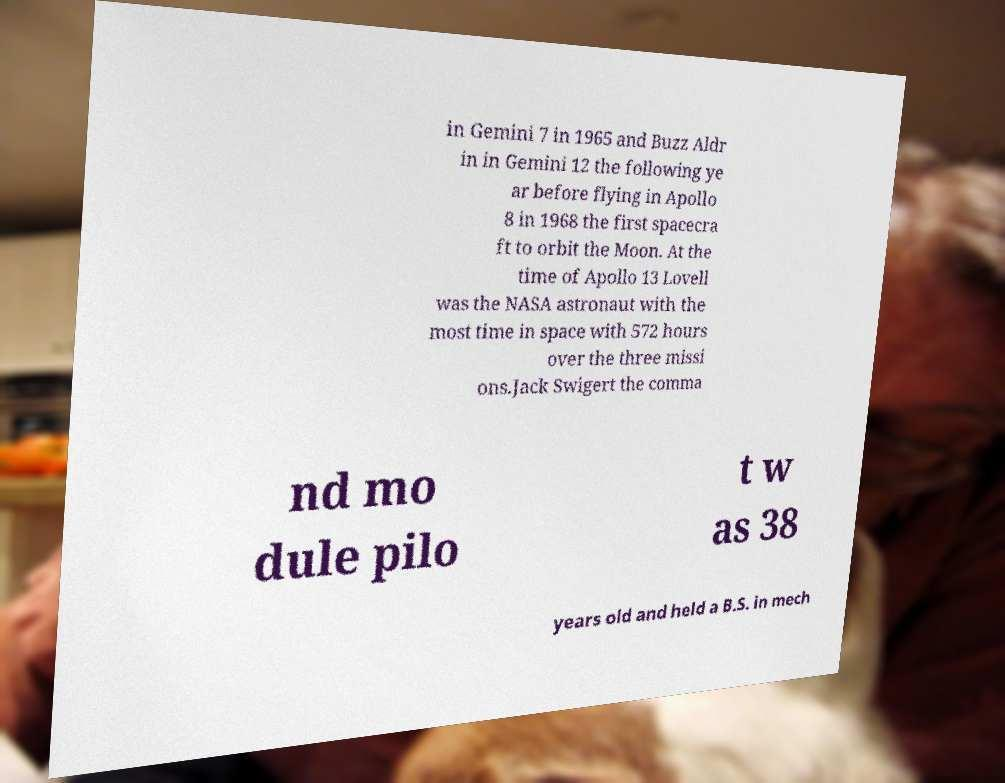Could you extract and type out the text from this image? in Gemini 7 in 1965 and Buzz Aldr in in Gemini 12 the following ye ar before flying in Apollo 8 in 1968 the first spacecra ft to orbit the Moon. At the time of Apollo 13 Lovell was the NASA astronaut with the most time in space with 572 hours over the three missi ons.Jack Swigert the comma nd mo dule pilo t w as 38 years old and held a B.S. in mech 